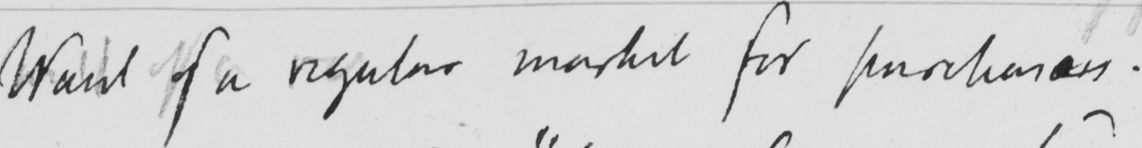Can you tell me what this handwritten text says? Want of a regular market for purchasers . 